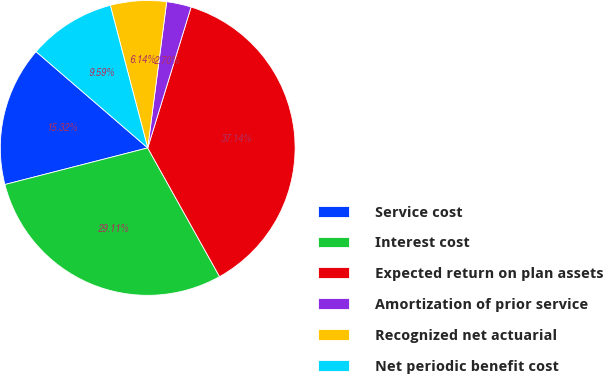Convert chart. <chart><loc_0><loc_0><loc_500><loc_500><pie_chart><fcel>Service cost<fcel>Interest cost<fcel>Expected return on plan assets<fcel>Amortization of prior service<fcel>Recognized net actuarial<fcel>Net periodic benefit cost<nl><fcel>15.32%<fcel>29.11%<fcel>37.14%<fcel>2.7%<fcel>6.14%<fcel>9.59%<nl></chart> 